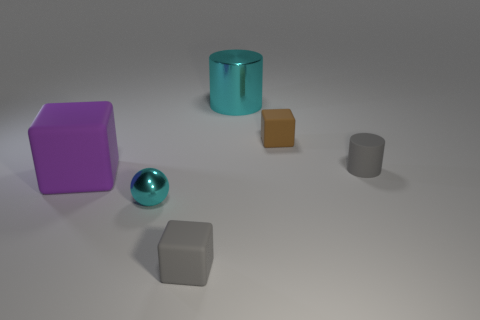What color is the tiny matte cube that is behind the small gray matte thing that is right of the thing in front of the small metallic thing?
Make the answer very short. Brown. What number of other objects are there of the same material as the tiny cyan ball?
Offer a very short reply. 1. Do the cyan metal object in front of the large purple rubber object and the large cyan metallic thing have the same shape?
Your response must be concise. No. How many tiny things are either yellow metallic blocks or cyan cylinders?
Give a very brief answer. 0. Is the number of gray objects that are on the right side of the big cyan cylinder the same as the number of big metallic cylinders in front of the small gray block?
Offer a very short reply. No. How many other things are the same color as the small sphere?
Offer a terse response. 1. Does the big metallic cylinder have the same color as the big object that is to the left of the cyan shiny sphere?
Provide a short and direct response. No. How many gray objects are either big metallic cylinders or tiny shiny balls?
Offer a terse response. 0. Is the number of cyan metallic cylinders that are to the left of the big purple rubber block the same as the number of big purple blocks?
Offer a very short reply. No. Is there anything else that is the same size as the purple rubber block?
Ensure brevity in your answer.  Yes. 